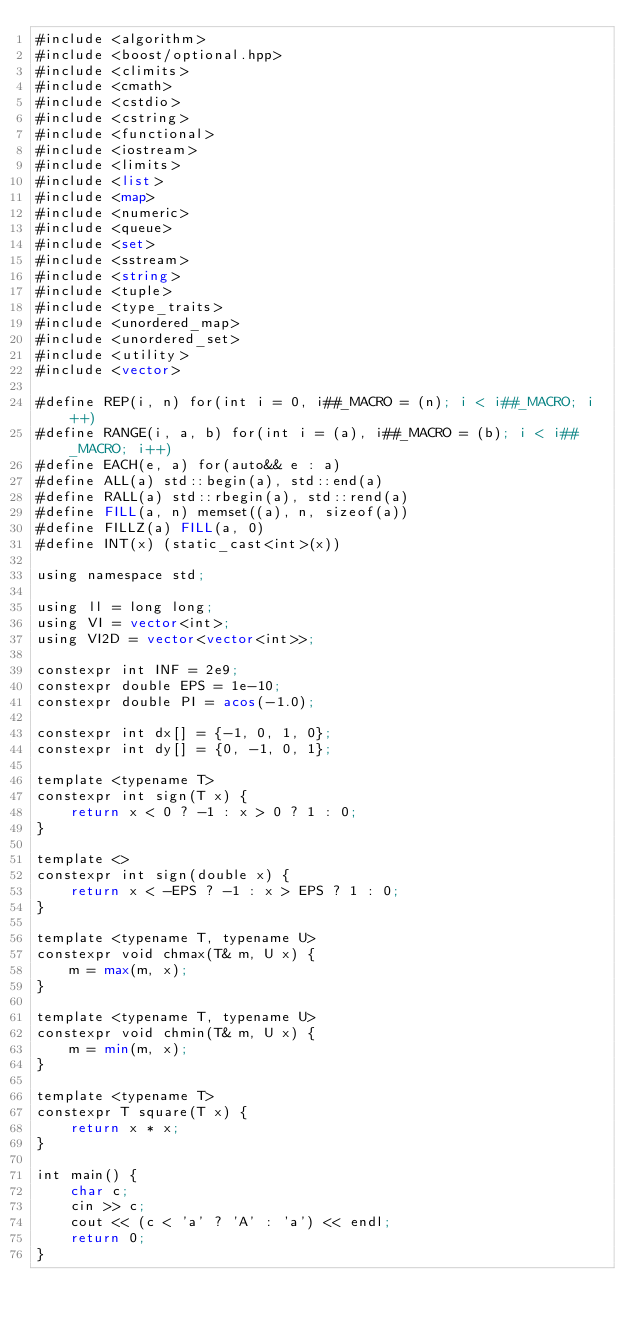<code> <loc_0><loc_0><loc_500><loc_500><_Lisp_>#include <algorithm>
#include <boost/optional.hpp>
#include <climits>
#include <cmath>
#include <cstdio>
#include <cstring>
#include <functional>
#include <iostream>
#include <limits>
#include <list>
#include <map>
#include <numeric>
#include <queue>
#include <set>
#include <sstream>
#include <string>
#include <tuple>
#include <type_traits>
#include <unordered_map>
#include <unordered_set>
#include <utility>
#include <vector>

#define REP(i, n) for(int i = 0, i##_MACRO = (n); i < i##_MACRO; i++)
#define RANGE(i, a, b) for(int i = (a), i##_MACRO = (b); i < i##_MACRO; i++)
#define EACH(e, a) for(auto&& e : a)
#define ALL(a) std::begin(a), std::end(a)
#define RALL(a) std::rbegin(a), std::rend(a)
#define FILL(a, n) memset((a), n, sizeof(a))
#define FILLZ(a) FILL(a, 0)
#define INT(x) (static_cast<int>(x))

using namespace std;

using ll = long long;
using VI = vector<int>;
using VI2D = vector<vector<int>>;

constexpr int INF = 2e9;
constexpr double EPS = 1e-10;
constexpr double PI = acos(-1.0);

constexpr int dx[] = {-1, 0, 1, 0};
constexpr int dy[] = {0, -1, 0, 1};

template <typename T>
constexpr int sign(T x) {
	return x < 0 ? -1 : x > 0 ? 1 : 0;
}

template <>
constexpr int sign(double x) {
	return x < -EPS ? -1 : x > EPS ? 1 : 0;
}

template <typename T, typename U>
constexpr void chmax(T& m, U x) {
	m = max(m, x);
}

template <typename T, typename U>
constexpr void chmin(T& m, U x) {
	m = min(m, x);
}

template <typename T>
constexpr T square(T x) {
	return x * x;
}

int main() {
	char c;
	cin >> c;
	cout << (c < 'a' ? 'A' : 'a') << endl;
	return 0;
}
</code> 